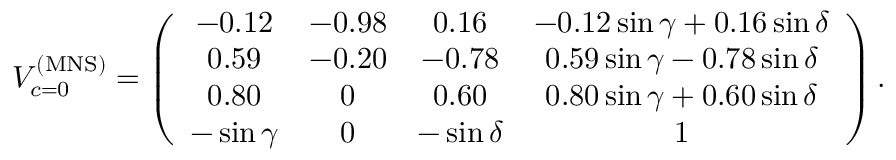Convert formula to latex. <formula><loc_0><loc_0><loc_500><loc_500>V _ { c = 0 } ^ { ( M N S ) } = \left ( \begin{array} { c c c c } { - 0 . 1 2 } & { - 0 . 9 8 } & { 0 . 1 6 } & { - 0 . 1 2 \sin \gamma + 0 . 1 6 \sin \delta } \\ { 0 . 5 9 } & { - 0 . 2 0 } & { - 0 . 7 8 } & { 0 . 5 9 \sin \gamma - 0 . 7 8 \sin \delta } \\ { 0 . 8 0 } & { 0 } & { 0 . 6 0 } & { 0 . 8 0 \sin \gamma + 0 . 6 0 \sin \delta } \\ { - \sin \gamma } & { 0 } & { - \sin \delta } & { 1 } \end{array} \right ) .</formula> 